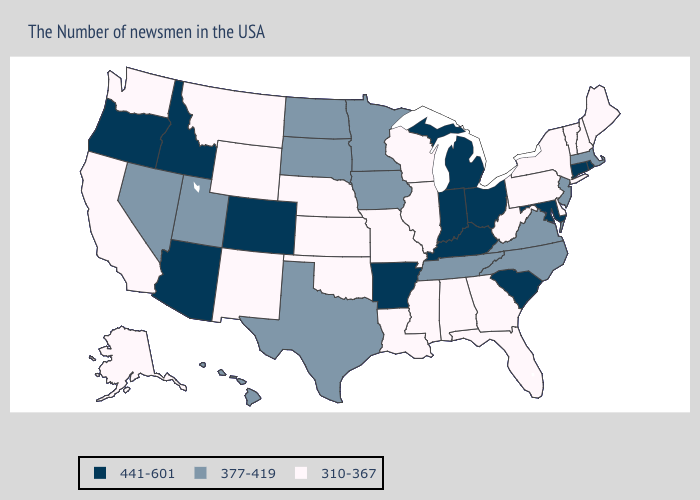What is the lowest value in the Northeast?
Be succinct. 310-367. What is the highest value in states that border New Mexico?
Answer briefly. 441-601. What is the value of Missouri?
Give a very brief answer. 310-367. Does the map have missing data?
Concise answer only. No. What is the lowest value in states that border Nevada?
Quick response, please. 310-367. Name the states that have a value in the range 310-367?
Keep it brief. Maine, New Hampshire, Vermont, New York, Delaware, Pennsylvania, West Virginia, Florida, Georgia, Alabama, Wisconsin, Illinois, Mississippi, Louisiana, Missouri, Kansas, Nebraska, Oklahoma, Wyoming, New Mexico, Montana, California, Washington, Alaska. What is the value of Colorado?
Write a very short answer. 441-601. Does the map have missing data?
Answer briefly. No. What is the value of Virginia?
Short answer required. 377-419. Does Arkansas have a higher value than Connecticut?
Give a very brief answer. No. Name the states that have a value in the range 441-601?
Keep it brief. Rhode Island, Connecticut, Maryland, South Carolina, Ohio, Michigan, Kentucky, Indiana, Arkansas, Colorado, Arizona, Idaho, Oregon. What is the value of South Dakota?
Answer briefly. 377-419. What is the lowest value in states that border Delaware?
Keep it brief. 310-367. Name the states that have a value in the range 377-419?
Give a very brief answer. Massachusetts, New Jersey, Virginia, North Carolina, Tennessee, Minnesota, Iowa, Texas, South Dakota, North Dakota, Utah, Nevada, Hawaii. What is the value of Iowa?
Write a very short answer. 377-419. 